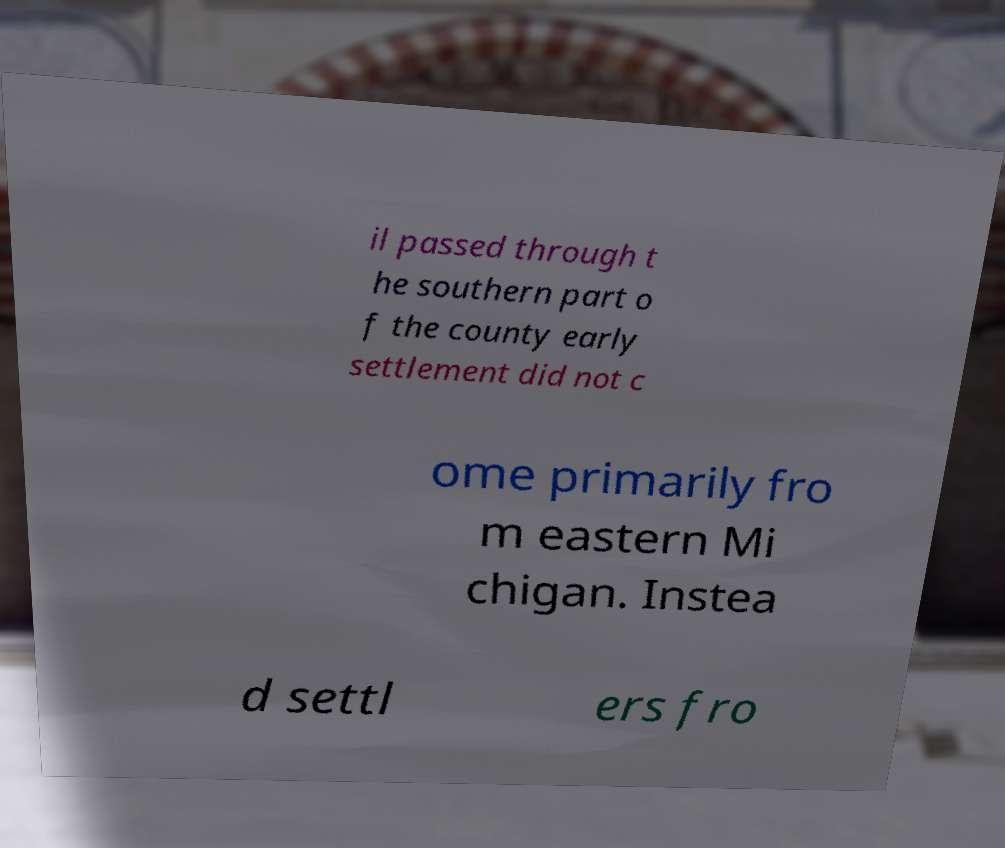What messages or text are displayed in this image? I need them in a readable, typed format. il passed through t he southern part o f the county early settlement did not c ome primarily fro m eastern Mi chigan. Instea d settl ers fro 